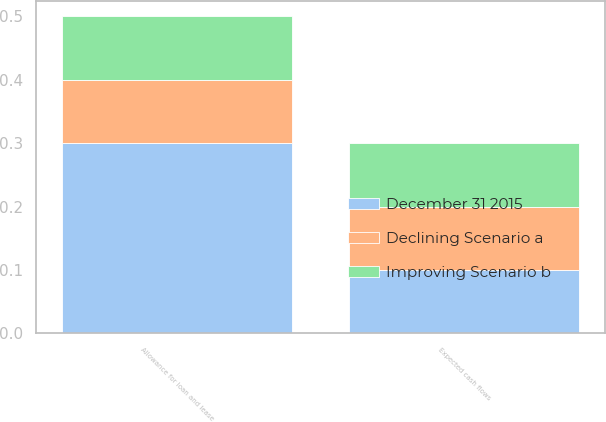Convert chart. <chart><loc_0><loc_0><loc_500><loc_500><stacked_bar_chart><ecel><fcel>Expected cash flows<fcel>Allowance for loan and lease<nl><fcel>December 31 2015<fcel>0.1<fcel>0.3<nl><fcel>Improving Scenario b<fcel>0.1<fcel>0.1<nl><fcel>Declining Scenario a<fcel>0.1<fcel>0.1<nl></chart> 